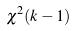<formula> <loc_0><loc_0><loc_500><loc_500>\chi ^ { 2 } ( k - 1 )</formula> 